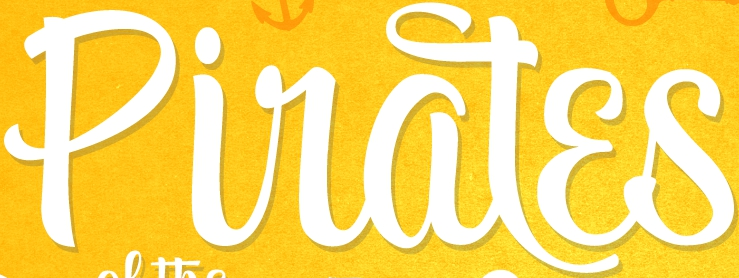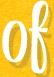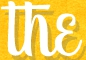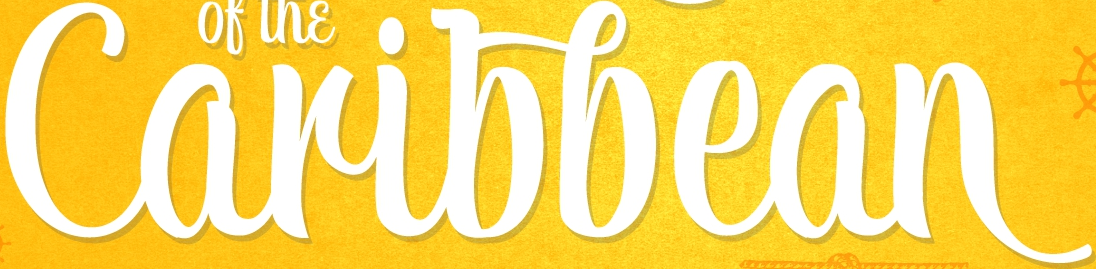What text appears in these images from left to right, separated by a semicolon? Piratɛs; of; the; Caribbean 